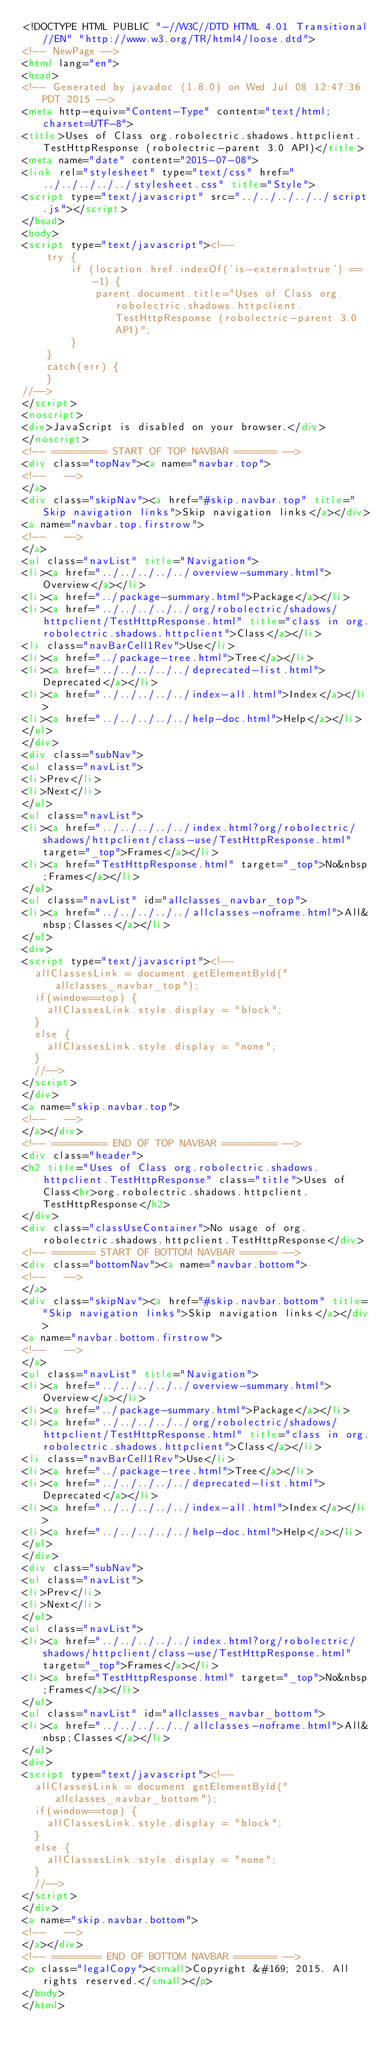Convert code to text. <code><loc_0><loc_0><loc_500><loc_500><_HTML_><!DOCTYPE HTML PUBLIC "-//W3C//DTD HTML 4.01 Transitional//EN" "http://www.w3.org/TR/html4/loose.dtd">
<!-- NewPage -->
<html lang="en">
<head>
<!-- Generated by javadoc (1.8.0) on Wed Jul 08 12:47:36 PDT 2015 -->
<meta http-equiv="Content-Type" content="text/html; charset=UTF-8">
<title>Uses of Class org.robolectric.shadows.httpclient.TestHttpResponse (robolectric-parent 3.0 API)</title>
<meta name="date" content="2015-07-08">
<link rel="stylesheet" type="text/css" href="../../../../../stylesheet.css" title="Style">
<script type="text/javascript" src="../../../../../script.js"></script>
</head>
<body>
<script type="text/javascript"><!--
    try {
        if (location.href.indexOf('is-external=true') == -1) {
            parent.document.title="Uses of Class org.robolectric.shadows.httpclient.TestHttpResponse (robolectric-parent 3.0 API)";
        }
    }
    catch(err) {
    }
//-->
</script>
<noscript>
<div>JavaScript is disabled on your browser.</div>
</noscript>
<!-- ========= START OF TOP NAVBAR ======= -->
<div class="topNav"><a name="navbar.top">
<!--   -->
</a>
<div class="skipNav"><a href="#skip.navbar.top" title="Skip navigation links">Skip navigation links</a></div>
<a name="navbar.top.firstrow">
<!--   -->
</a>
<ul class="navList" title="Navigation">
<li><a href="../../../../../overview-summary.html">Overview</a></li>
<li><a href="../package-summary.html">Package</a></li>
<li><a href="../../../../../org/robolectric/shadows/httpclient/TestHttpResponse.html" title="class in org.robolectric.shadows.httpclient">Class</a></li>
<li class="navBarCell1Rev">Use</li>
<li><a href="../package-tree.html">Tree</a></li>
<li><a href="../../../../../deprecated-list.html">Deprecated</a></li>
<li><a href="../../../../../index-all.html">Index</a></li>
<li><a href="../../../../../help-doc.html">Help</a></li>
</ul>
</div>
<div class="subNav">
<ul class="navList">
<li>Prev</li>
<li>Next</li>
</ul>
<ul class="navList">
<li><a href="../../../../../index.html?org/robolectric/shadows/httpclient/class-use/TestHttpResponse.html" target="_top">Frames</a></li>
<li><a href="TestHttpResponse.html" target="_top">No&nbsp;Frames</a></li>
</ul>
<ul class="navList" id="allclasses_navbar_top">
<li><a href="../../../../../allclasses-noframe.html">All&nbsp;Classes</a></li>
</ul>
<div>
<script type="text/javascript"><!--
  allClassesLink = document.getElementById("allclasses_navbar_top");
  if(window==top) {
    allClassesLink.style.display = "block";
  }
  else {
    allClassesLink.style.display = "none";
  }
  //-->
</script>
</div>
<a name="skip.navbar.top">
<!--   -->
</a></div>
<!-- ========= END OF TOP NAVBAR ========= -->
<div class="header">
<h2 title="Uses of Class org.robolectric.shadows.httpclient.TestHttpResponse" class="title">Uses of Class<br>org.robolectric.shadows.httpclient.TestHttpResponse</h2>
</div>
<div class="classUseContainer">No usage of org.robolectric.shadows.httpclient.TestHttpResponse</div>
<!-- ======= START OF BOTTOM NAVBAR ====== -->
<div class="bottomNav"><a name="navbar.bottom">
<!--   -->
</a>
<div class="skipNav"><a href="#skip.navbar.bottom" title="Skip navigation links">Skip navigation links</a></div>
<a name="navbar.bottom.firstrow">
<!--   -->
</a>
<ul class="navList" title="Navigation">
<li><a href="../../../../../overview-summary.html">Overview</a></li>
<li><a href="../package-summary.html">Package</a></li>
<li><a href="../../../../../org/robolectric/shadows/httpclient/TestHttpResponse.html" title="class in org.robolectric.shadows.httpclient">Class</a></li>
<li class="navBarCell1Rev">Use</li>
<li><a href="../package-tree.html">Tree</a></li>
<li><a href="../../../../../deprecated-list.html">Deprecated</a></li>
<li><a href="../../../../../index-all.html">Index</a></li>
<li><a href="../../../../../help-doc.html">Help</a></li>
</ul>
</div>
<div class="subNav">
<ul class="navList">
<li>Prev</li>
<li>Next</li>
</ul>
<ul class="navList">
<li><a href="../../../../../index.html?org/robolectric/shadows/httpclient/class-use/TestHttpResponse.html" target="_top">Frames</a></li>
<li><a href="TestHttpResponse.html" target="_top">No&nbsp;Frames</a></li>
</ul>
<ul class="navList" id="allclasses_navbar_bottom">
<li><a href="../../../../../allclasses-noframe.html">All&nbsp;Classes</a></li>
</ul>
<div>
<script type="text/javascript"><!--
  allClassesLink = document.getElementById("allclasses_navbar_bottom");
  if(window==top) {
    allClassesLink.style.display = "block";
  }
  else {
    allClassesLink.style.display = "none";
  }
  //-->
</script>
</div>
<a name="skip.navbar.bottom">
<!--   -->
</a></div>
<!-- ======== END OF BOTTOM NAVBAR ======= -->
<p class="legalCopy"><small>Copyright &#169; 2015. All rights reserved.</small></p>
</body>
</html>
</code> 